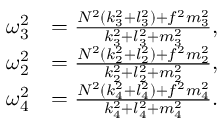<formula> <loc_0><loc_0><loc_500><loc_500>\begin{array} { r l } { \omega _ { 3 } ^ { 2 } } & { = \frac { N ^ { 2 } ( k _ { 3 } ^ { 2 } + l _ { 3 } ^ { 2 } ) + f ^ { 2 } m _ { 3 } ^ { 2 } } { k _ { 3 } ^ { 2 } + l _ { 3 } ^ { 2 } + m _ { 3 } ^ { 2 } } , } \\ { \omega _ { 2 } ^ { 2 } } & { = \frac { N ^ { 2 } ( k _ { 2 } ^ { 2 } + l _ { 2 } ^ { 2 } ) + f ^ { 2 } m _ { 2 } ^ { 2 } } { k _ { 2 } ^ { 2 } + l _ { 2 } ^ { 2 } + m _ { 2 } ^ { 2 } } , } \\ { \omega _ { 4 } ^ { 2 } } & { = \frac { N ^ { 2 } ( k _ { 4 } ^ { 2 } + l _ { 4 } ^ { 2 } ) + f ^ { 2 } m _ { 4 } ^ { 2 } } { k _ { 4 } ^ { 2 } + l _ { 4 } ^ { 2 } + m _ { 4 } ^ { 2 } } . } \end{array}</formula> 